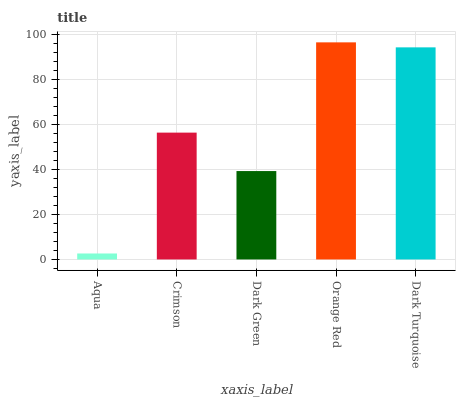Is Aqua the minimum?
Answer yes or no. Yes. Is Orange Red the maximum?
Answer yes or no. Yes. Is Crimson the minimum?
Answer yes or no. No. Is Crimson the maximum?
Answer yes or no. No. Is Crimson greater than Aqua?
Answer yes or no. Yes. Is Aqua less than Crimson?
Answer yes or no. Yes. Is Aqua greater than Crimson?
Answer yes or no. No. Is Crimson less than Aqua?
Answer yes or no. No. Is Crimson the high median?
Answer yes or no. Yes. Is Crimson the low median?
Answer yes or no. Yes. Is Orange Red the high median?
Answer yes or no. No. Is Aqua the low median?
Answer yes or no. No. 